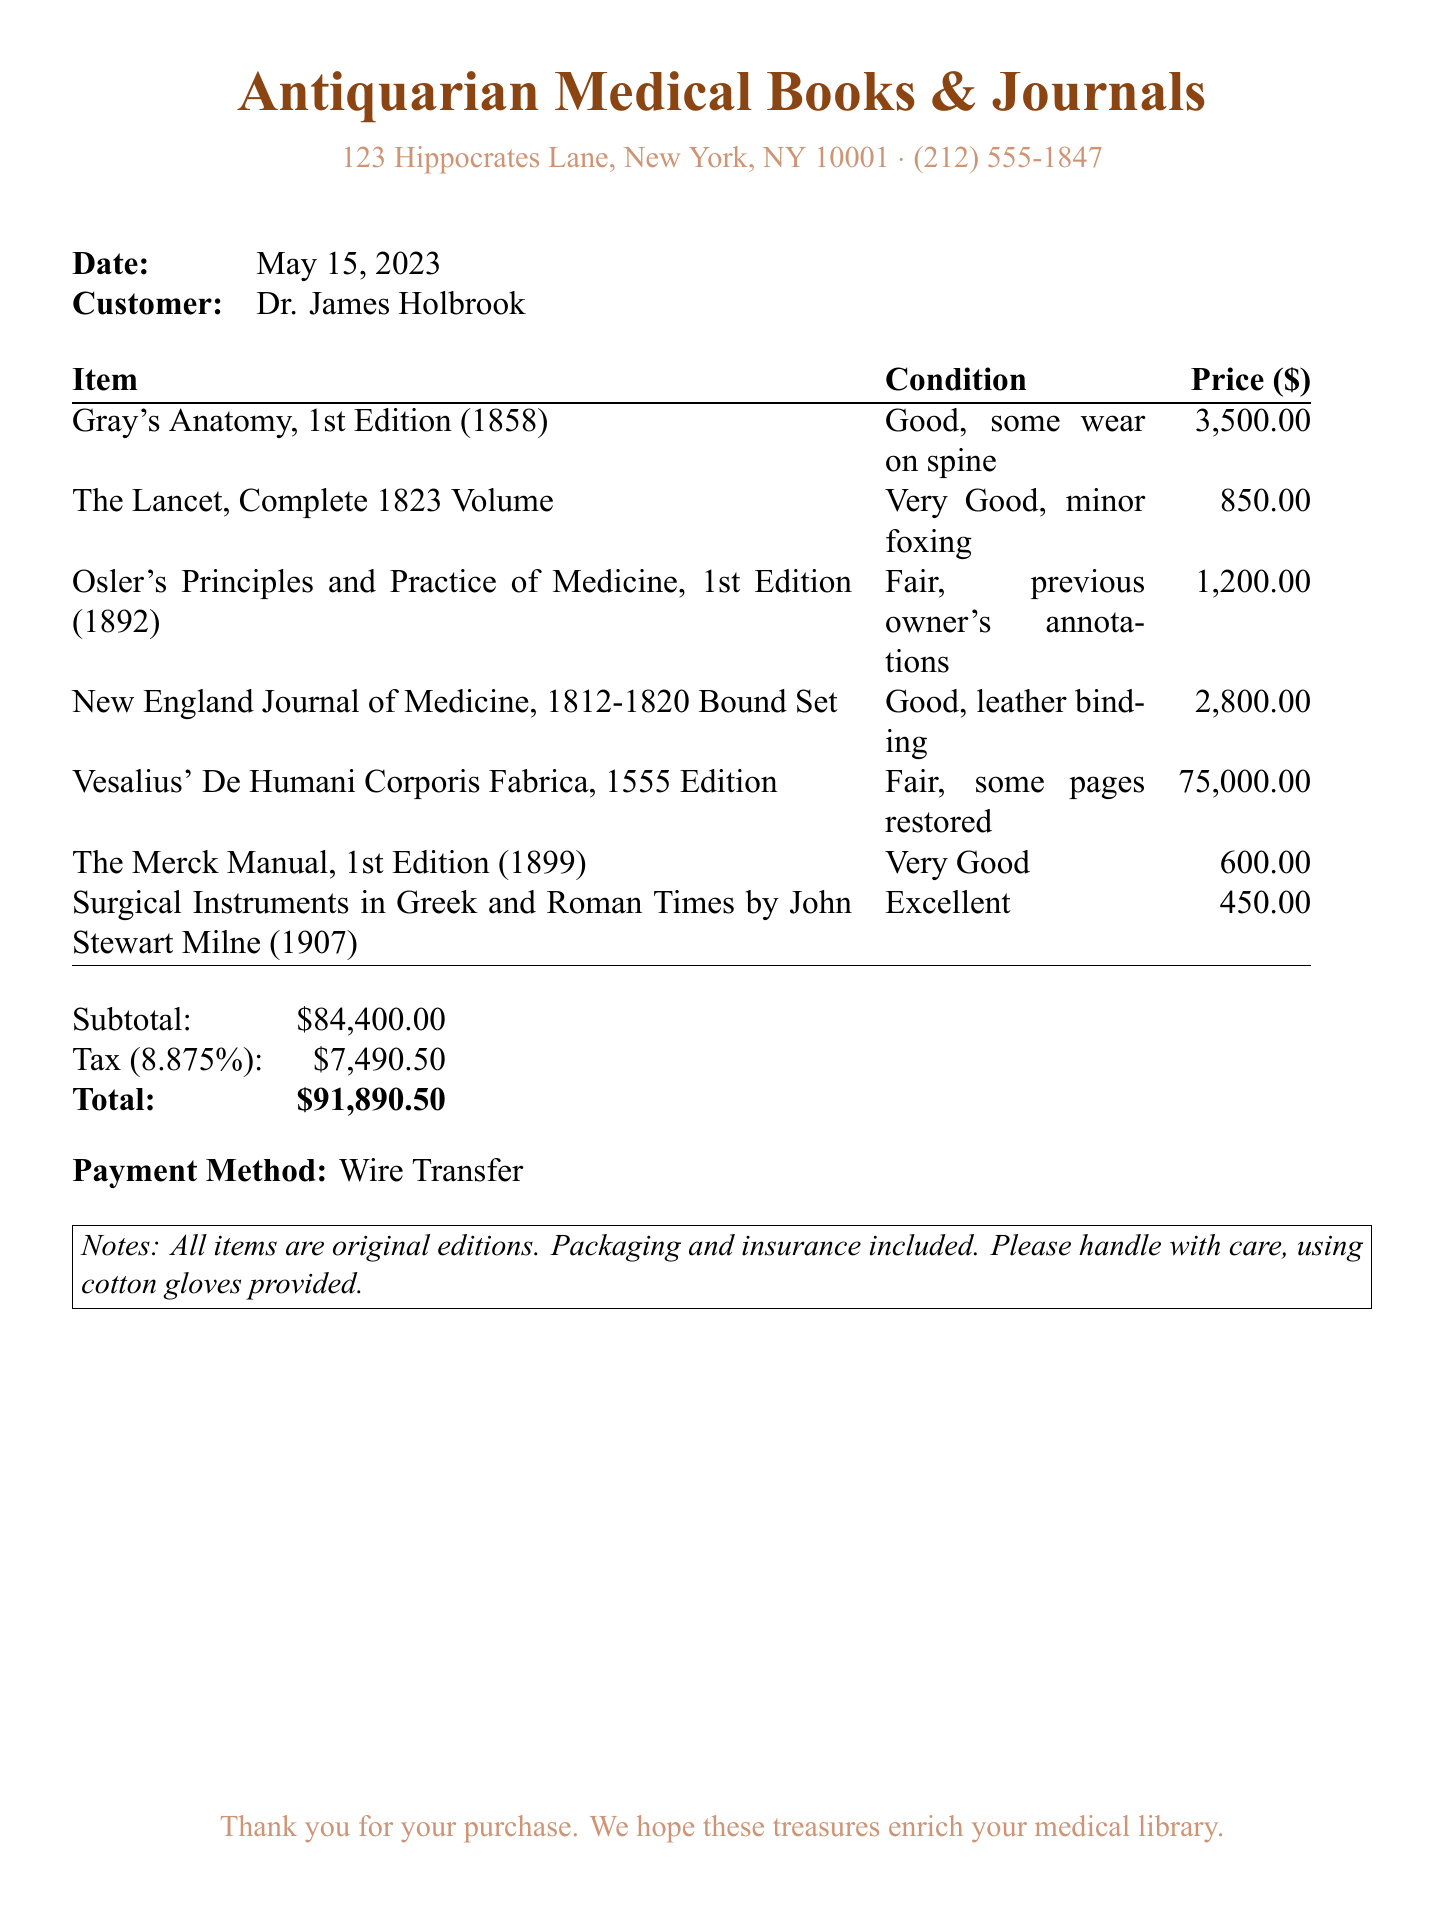What is the name of the bookstore? The name of the bookstore is provided at the top of the receipt.
Answer: Antiquarian Medical Books & Journals What is the total amount due? The total amount due is stated in the final section of the receipt.
Answer: $91,890.50 What date was the purchase made? The date of the purchase is mentioned in the document.
Answer: May 15, 2023 How many items were purchased? The number of items can be tallied from the itemized list provided.
Answer: 7 What was the condition of "Vesalius' De Humani Corporis Fabrica, 1555 Edition"? The condition of this specific book is detailed in the item list.
Answer: Fair, some pages restored What payment method was used? The payment method is specified towards the end of the receipt.
Answer: Wire Transfer What is the subtotal before tax? The subtotal is given before the tax calculation on the receipt.
Answer: $84,400.00 What is noted about the items in the receipt? The notes section at the bottom mentions important information regarding the items.
Answer: All items are original editions 